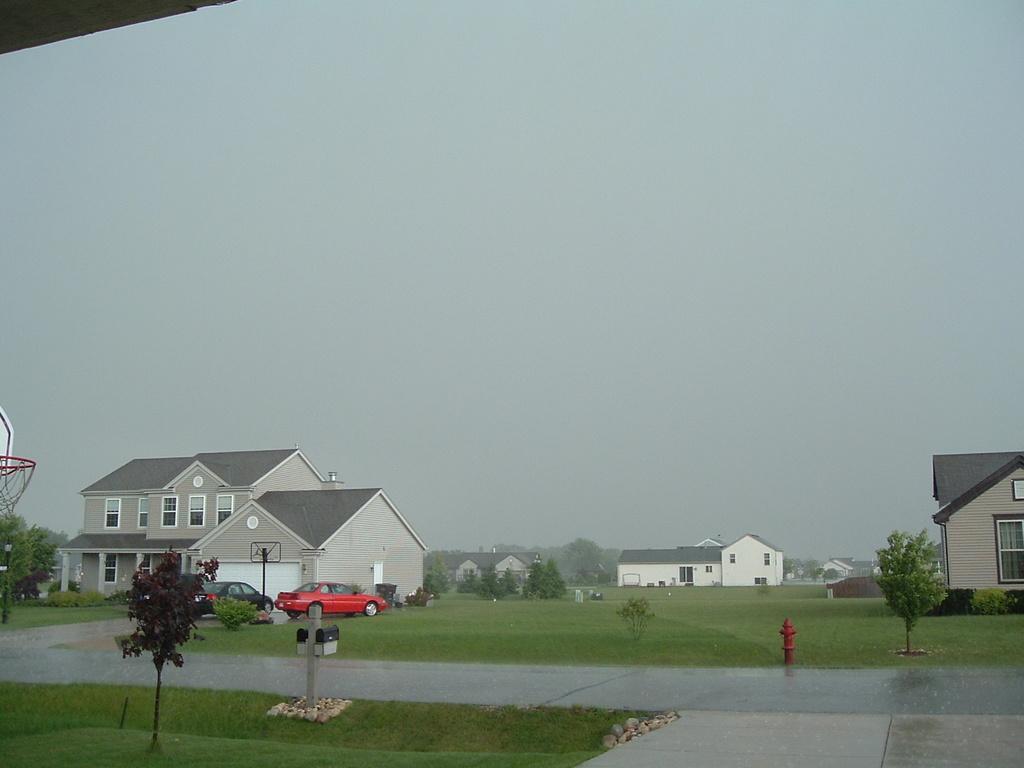Please provide a concise description of this image. In this image there are plants. There are poles, stones. In the center of the image there is a road. There are cars. At the bottom of the image there is grass on the surface. On the left side of the image there is a basketball court. In the background of the image there are buildings, trees and sky. 